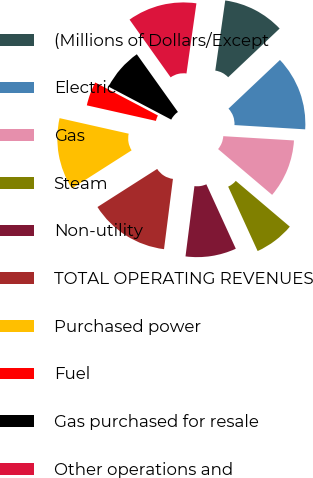Convert chart to OTSL. <chart><loc_0><loc_0><loc_500><loc_500><pie_chart><fcel>(Millions of Dollars/Except<fcel>Electric<fcel>Gas<fcel>Steam<fcel>Non-utility<fcel>TOTAL OPERATING REVENUES<fcel>Purchased power<fcel>Fuel<fcel>Gas purchased for resale<fcel>Other operations and<nl><fcel>10.7%<fcel>13.02%<fcel>10.23%<fcel>6.98%<fcel>8.84%<fcel>13.95%<fcel>12.56%<fcel>4.19%<fcel>7.44%<fcel>12.09%<nl></chart> 